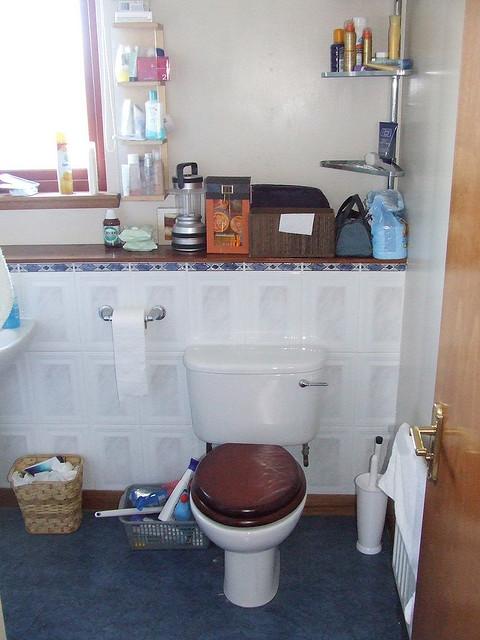Does the trash need to be taken out?
Keep it brief. Yes. Is the bathroom cluttered?
Be succinct. Yes. Is the toilet lid up or down?
Concise answer only. Down. 